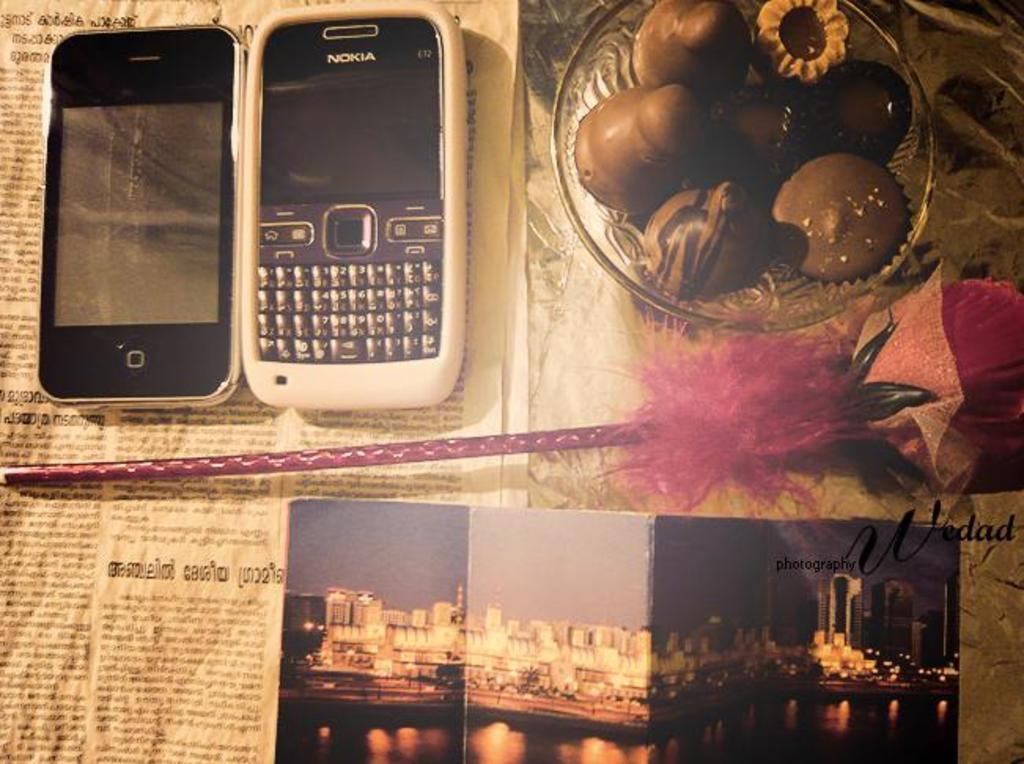<image>
Give a short and clear explanation of the subsequent image. A Nokia cell phone and an iPhone are by a bowl of chocolates and a postcard. 